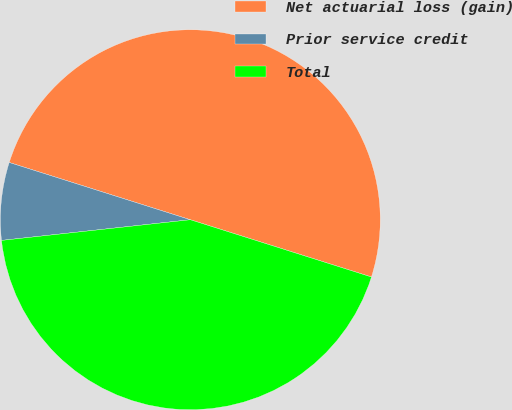Convert chart to OTSL. <chart><loc_0><loc_0><loc_500><loc_500><pie_chart><fcel>Net actuarial loss (gain)<fcel>Prior service credit<fcel>Total<nl><fcel>50.0%<fcel>6.61%<fcel>43.39%<nl></chart> 